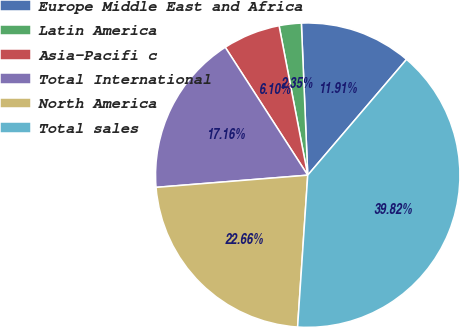Convert chart. <chart><loc_0><loc_0><loc_500><loc_500><pie_chart><fcel>Europe Middle East and Africa<fcel>Latin America<fcel>Asia-Pacifi c<fcel>Total International<fcel>North America<fcel>Total sales<nl><fcel>11.91%<fcel>2.35%<fcel>6.1%<fcel>17.16%<fcel>22.66%<fcel>39.82%<nl></chart> 